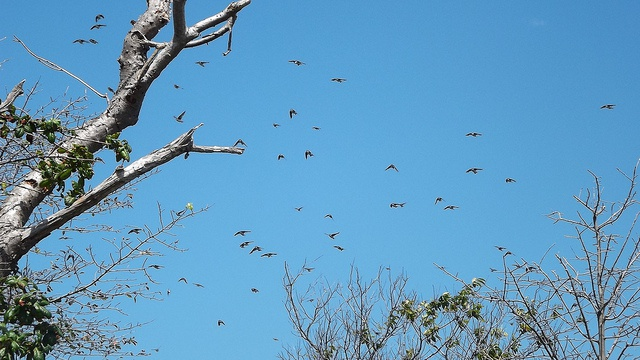Describe the objects in this image and their specific colors. I can see bird in gray and lightblue tones, bird in gray, lightblue, and black tones, bird in gray, lightblue, and black tones, bird in gray, lightblue, and black tones, and bird in gray, black, lightblue, and darkgray tones in this image. 